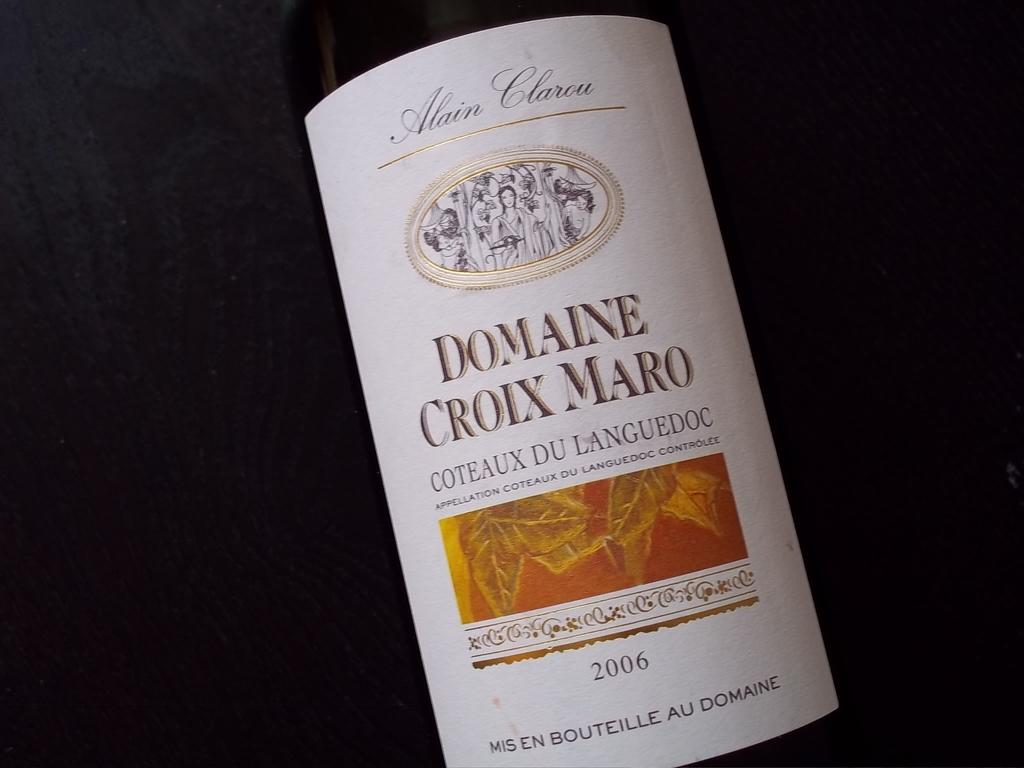What kind of wine is this?
Your response must be concise. Domaine croix maro. What year was the wine made?
Provide a short and direct response. 2006. 